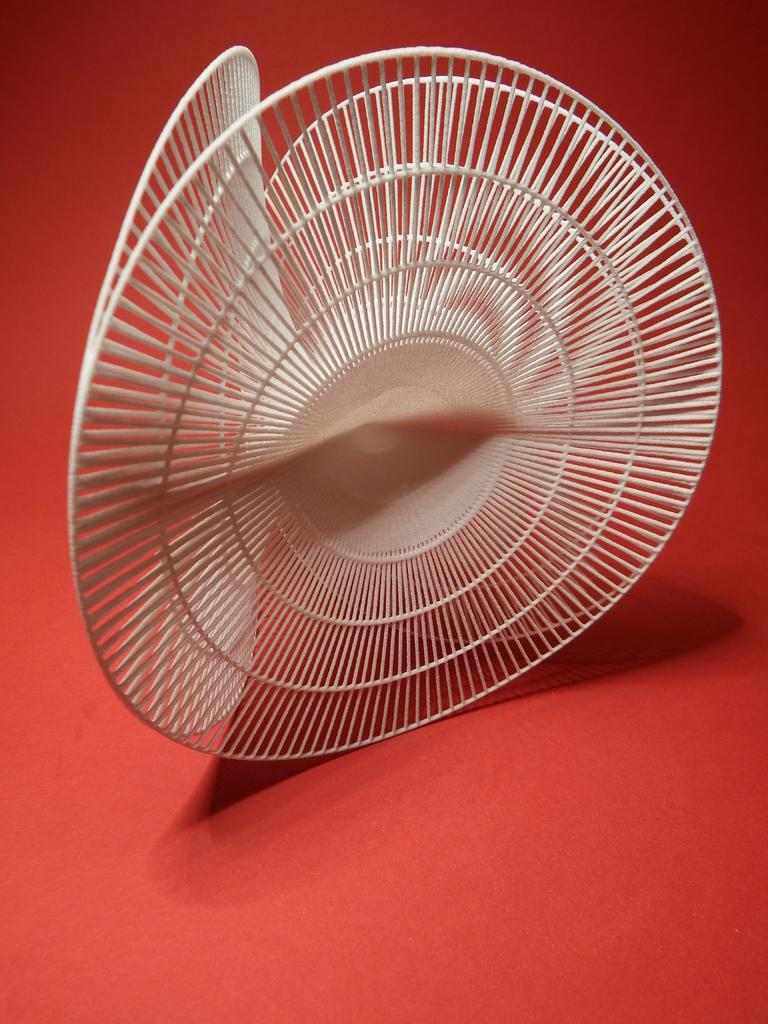Can you describe the object that is visible in the image? Unfortunately, the provided fact is quite vague and does not give enough information to accurately describe the object in the image. Where is the toy resting in the image? There is no toy present in the image, and therefore no such resting can be observed. 